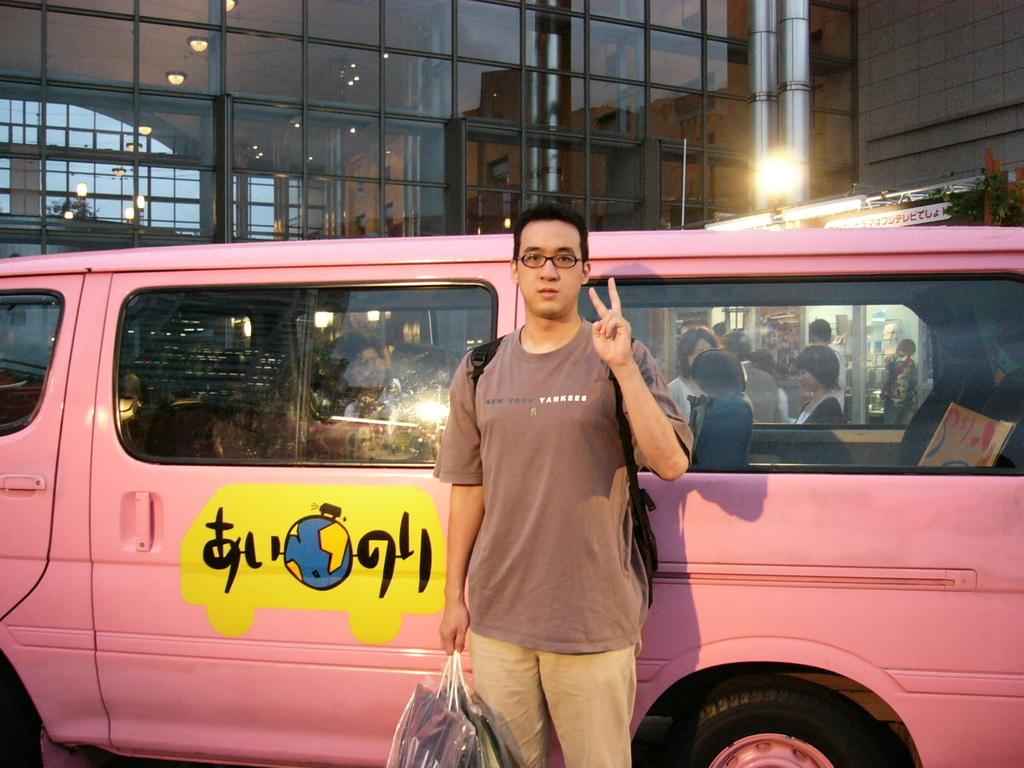<image>
Present a compact description of the photo's key features. A young man wearing a shirt that says New York Yankees stands in front of a pink van. 